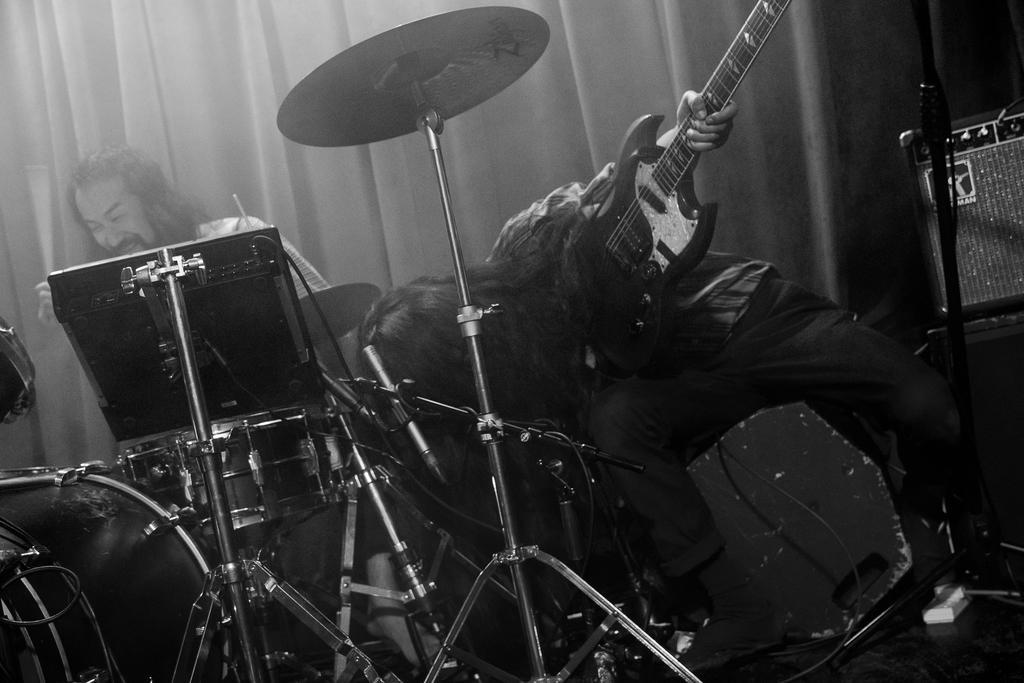How would you summarize this image in a sentence or two? In this image I can see two people. One person is holding guitar and another one is sitting in-front of the drum set. At the back there is a curtain. 